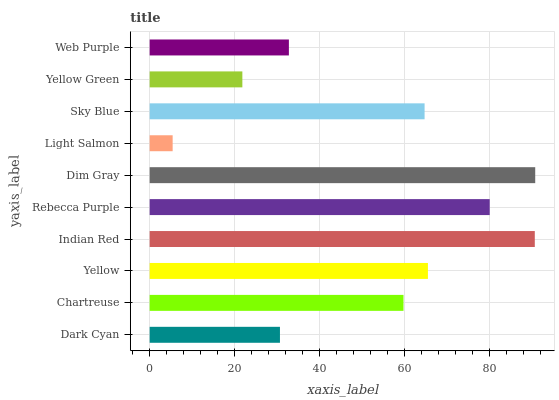Is Light Salmon the minimum?
Answer yes or no. Yes. Is Dim Gray the maximum?
Answer yes or no. Yes. Is Chartreuse the minimum?
Answer yes or no. No. Is Chartreuse the maximum?
Answer yes or no. No. Is Chartreuse greater than Dark Cyan?
Answer yes or no. Yes. Is Dark Cyan less than Chartreuse?
Answer yes or no. Yes. Is Dark Cyan greater than Chartreuse?
Answer yes or no. No. Is Chartreuse less than Dark Cyan?
Answer yes or no. No. Is Sky Blue the high median?
Answer yes or no. Yes. Is Chartreuse the low median?
Answer yes or no. Yes. Is Chartreuse the high median?
Answer yes or no. No. Is Light Salmon the low median?
Answer yes or no. No. 